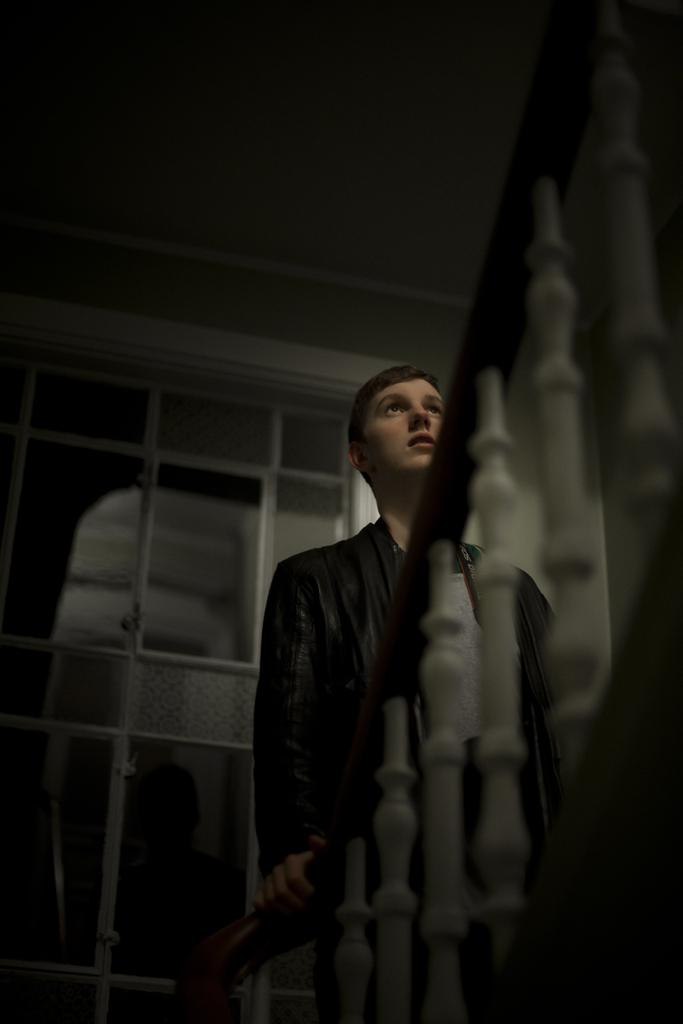Who is the main subject in the image? There is a boy in the center of the image. What can be seen in the background of the image? There is a window in the background of the image. What is in front of the boy? There is a boundary in front of the boy. Can you see a snail crawling on the boundary in the image? There is no snail present in the image. What type of bean is growing near the boy in the image? There are no beans present in the image. 